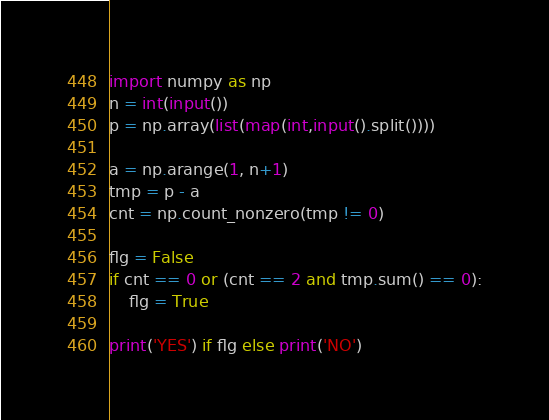Convert code to text. <code><loc_0><loc_0><loc_500><loc_500><_Python_>import numpy as np
n = int(input())
p = np.array(list(map(int,input().split())))

a = np.arange(1, n+1)
tmp = p - a
cnt = np.count_nonzero(tmp != 0)

flg = False
if cnt == 0 or (cnt == 2 and tmp.sum() == 0):
    flg = True

print('YES') if flg else print('NO')</code> 